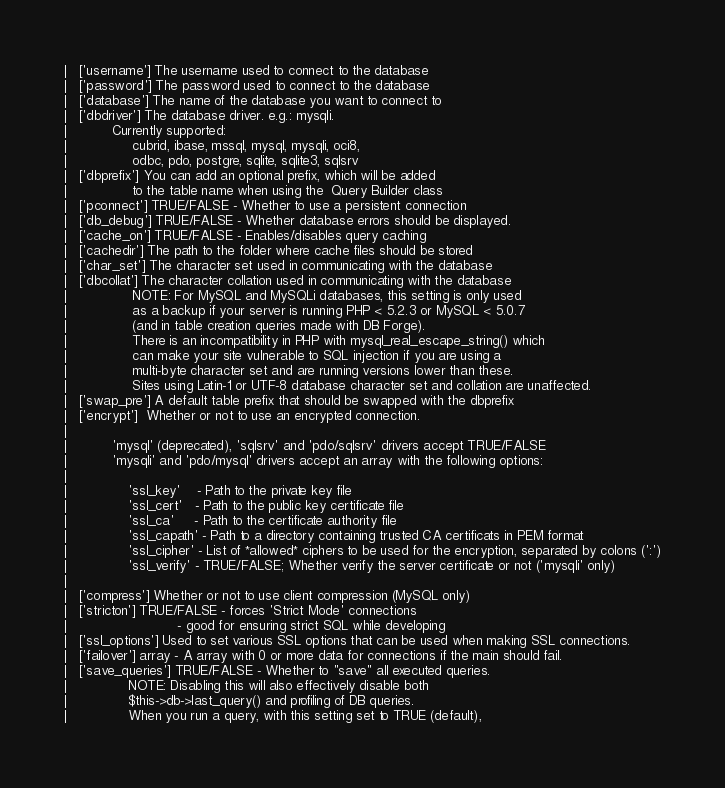<code> <loc_0><loc_0><loc_500><loc_500><_PHP_>|	['username'] The username used to connect to the database
|	['password'] The password used to connect to the database
|	['database'] The name of the database you want to connect to
|	['dbdriver'] The database driver. e.g.: mysqli.
|			Currently supported:
|				 cubrid, ibase, mssql, mysql, mysqli, oci8,
|				 odbc, pdo, postgre, sqlite, sqlite3, sqlsrv
|	['dbprefix'] You can add an optional prefix, which will be added
|				 to the table name when using the  Query Builder class
|	['pconnect'] TRUE/FALSE - Whether to use a persistent connection
|	['db_debug'] TRUE/FALSE - Whether database errors should be displayed.
|	['cache_on'] TRUE/FALSE - Enables/disables query caching
|	['cachedir'] The path to the folder where cache files should be stored
|	['char_set'] The character set used in communicating with the database
|	['dbcollat'] The character collation used in communicating with the database
|				 NOTE: For MySQL and MySQLi databases, this setting is only used
| 				 as a backup if your server is running PHP < 5.2.3 or MySQL < 5.0.7
|				 (and in table creation queries made with DB Forge).
| 				 There is an incompatibility in PHP with mysql_real_escape_string() which
| 				 can make your site vulnerable to SQL injection if you are using a
| 				 multi-byte character set and are running versions lower than these.
| 				 Sites using Latin-1 or UTF-8 database character set and collation are unaffected.
|	['swap_pre'] A default table prefix that should be swapped with the dbprefix
|	['encrypt']  Whether or not to use an encrypted connection.
|
|			'mysql' (deprecated), 'sqlsrv' and 'pdo/sqlsrv' drivers accept TRUE/FALSE
|			'mysqli' and 'pdo/mysql' drivers accept an array with the following options:
|
|				'ssl_key'    - Path to the private key file
|				'ssl_cert'   - Path to the public key certificate file
|				'ssl_ca'     - Path to the certificate authority file
|				'ssl_capath' - Path to a directory containing trusted CA certificats in PEM format
|				'ssl_cipher' - List of *allowed* ciphers to be used for the encryption, separated by colons (':')
|				'ssl_verify' - TRUE/FALSE; Whether verify the server certificate or not ('mysqli' only)
|
|	['compress'] Whether or not to use client compression (MySQL only)
|	['stricton'] TRUE/FALSE - forces 'Strict Mode' connections
|							- good for ensuring strict SQL while developing
|	['ssl_options']	Used to set various SSL options that can be used when making SSL connections.
|	['failover'] array - A array with 0 or more data for connections if the main should fail.
|	['save_queries'] TRUE/FALSE - Whether to "save" all executed queries.
| 				NOTE: Disabling this will also effectively disable both
| 				$this->db->last_query() and profiling of DB queries.
| 				When you run a query, with this setting set to TRUE (default),</code> 